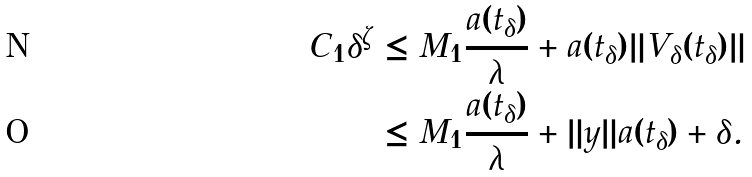Convert formula to latex. <formula><loc_0><loc_0><loc_500><loc_500>C _ { 1 } \delta ^ { \zeta } & \leq M _ { 1 } \frac { a ( t _ { \delta } ) } { \lambda } + a ( t _ { \delta } ) \| V _ { \delta } ( t _ { \delta } ) \| \\ & \leq M _ { 1 } \frac { a ( t _ { \delta } ) } { \lambda } + \| y \| a ( t _ { \delta } ) + \delta .</formula> 